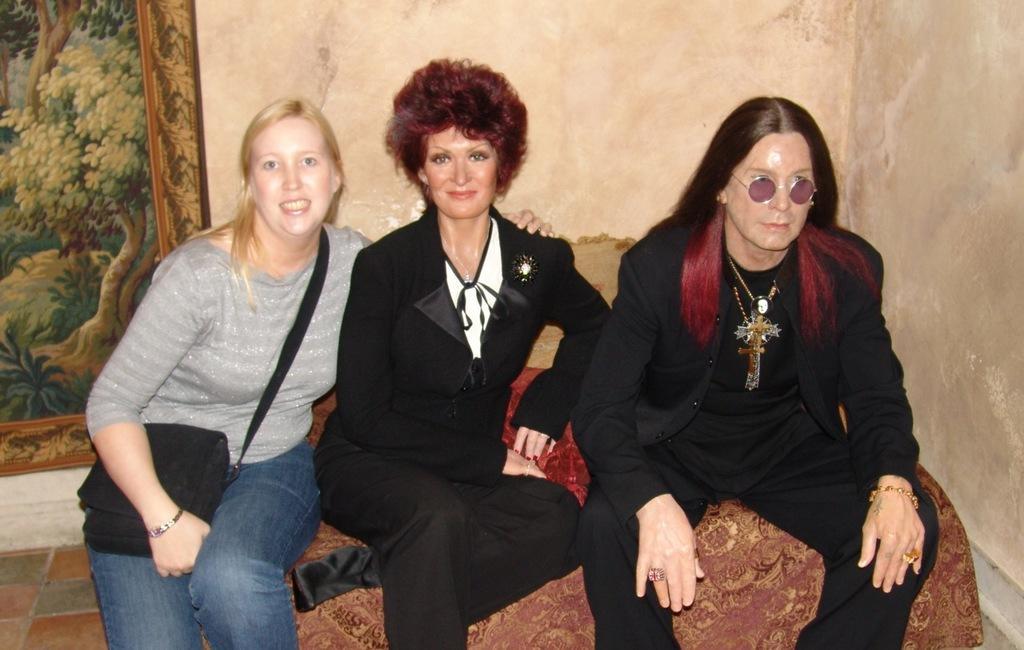Please provide a concise description of this image. In this image we can see three people sitting on the sofa. In the background there is a wall and we can see a frame placed on the wall. At the bottom there is a floor. 